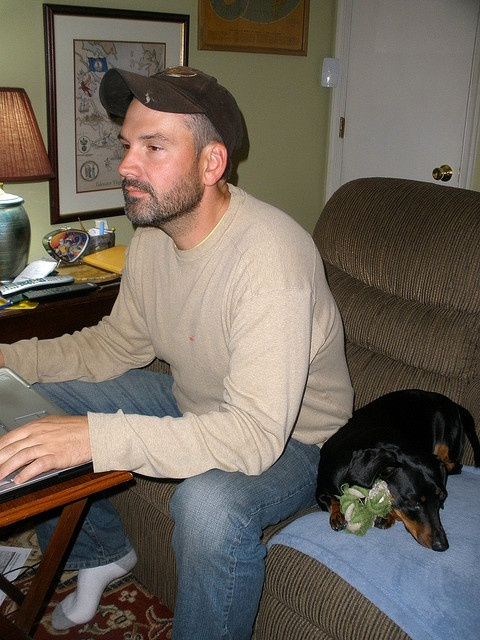Describe the objects in this image and their specific colors. I can see people in olive, darkgray, tan, and gray tones, couch in olive, black, and gray tones, dog in olive, black, maroon, and gray tones, laptop in olive, gray, black, darkgray, and maroon tones, and remote in olive, black, darkgray, white, and gray tones in this image. 